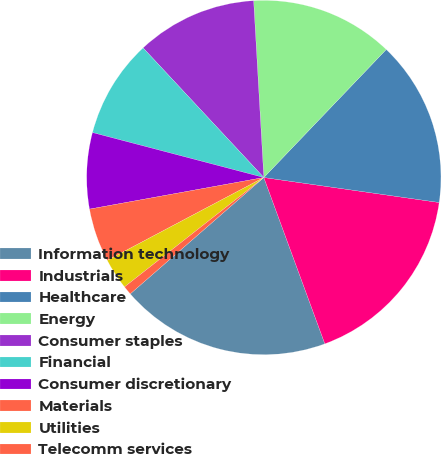<chart> <loc_0><loc_0><loc_500><loc_500><pie_chart><fcel>Information technology<fcel>Industrials<fcel>Healthcare<fcel>Energy<fcel>Consumer staples<fcel>Financial<fcel>Consumer discretionary<fcel>Materials<fcel>Utilities<fcel>Telecomm services<nl><fcel>19.19%<fcel>17.15%<fcel>15.11%<fcel>13.06%<fcel>11.02%<fcel>8.98%<fcel>6.94%<fcel>4.89%<fcel>2.85%<fcel>0.81%<nl></chart> 